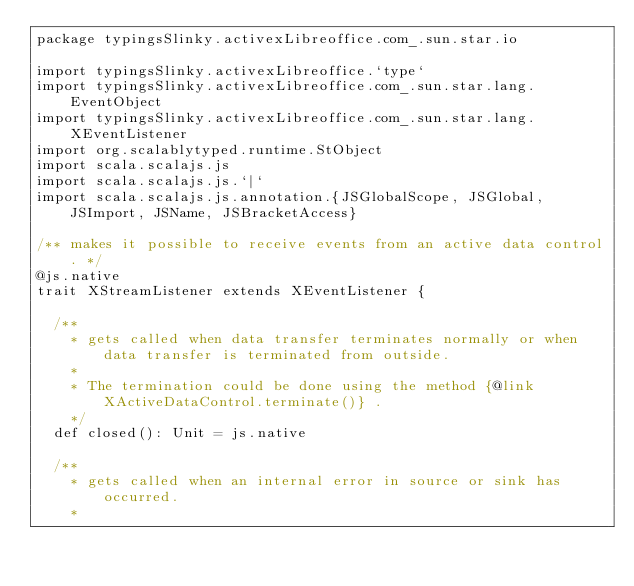Convert code to text. <code><loc_0><loc_0><loc_500><loc_500><_Scala_>package typingsSlinky.activexLibreoffice.com_.sun.star.io

import typingsSlinky.activexLibreoffice.`type`
import typingsSlinky.activexLibreoffice.com_.sun.star.lang.EventObject
import typingsSlinky.activexLibreoffice.com_.sun.star.lang.XEventListener
import org.scalablytyped.runtime.StObject
import scala.scalajs.js
import scala.scalajs.js.`|`
import scala.scalajs.js.annotation.{JSGlobalScope, JSGlobal, JSImport, JSName, JSBracketAccess}

/** makes it possible to receive events from an active data control. */
@js.native
trait XStreamListener extends XEventListener {
  
  /**
    * gets called when data transfer terminates normally or when data transfer is terminated from outside.
    *
    * The termination could be done using the method {@link XActiveDataControl.terminate()} .
    */
  def closed(): Unit = js.native
  
  /**
    * gets called when an internal error in source or sink has occurred.
    *</code> 